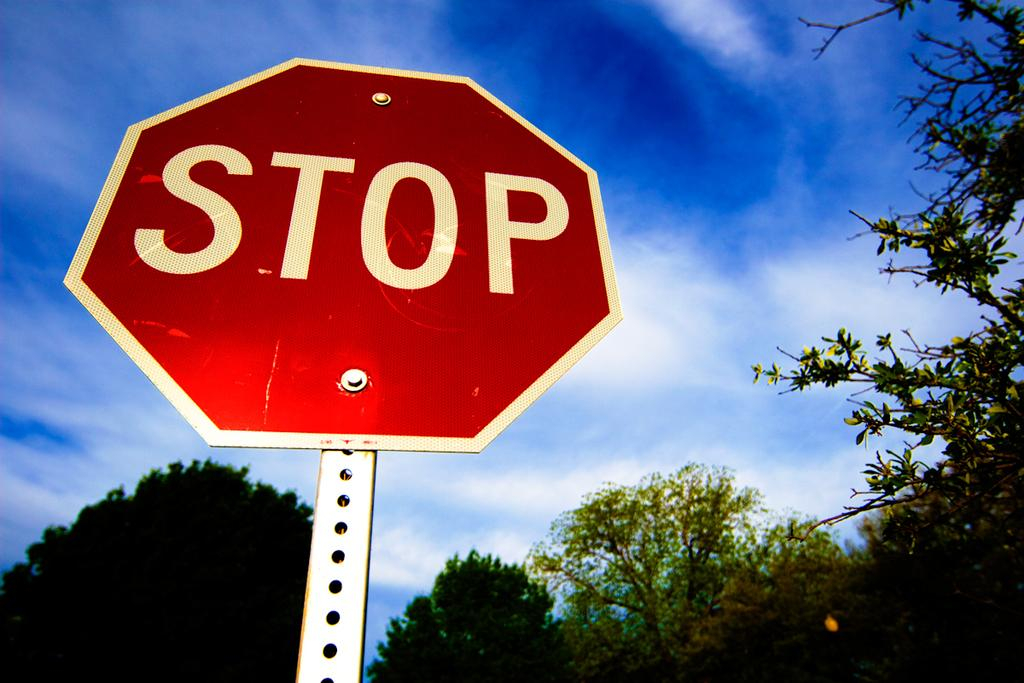<image>
Offer a succinct explanation of the picture presented. a stop sign that is outside in the daytime 